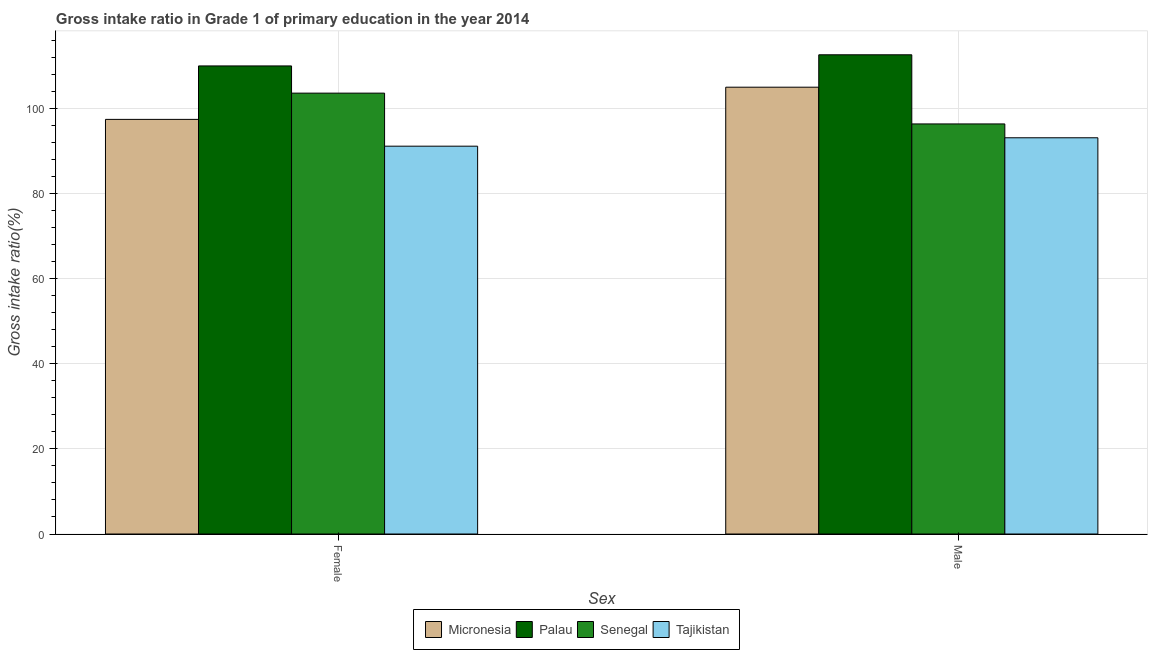How many different coloured bars are there?
Make the answer very short. 4. How many groups of bars are there?
Ensure brevity in your answer.  2. Are the number of bars per tick equal to the number of legend labels?
Make the answer very short. Yes. How many bars are there on the 1st tick from the left?
Make the answer very short. 4. What is the label of the 1st group of bars from the left?
Your answer should be compact. Female. What is the gross intake ratio(male) in Senegal?
Offer a terse response. 96.45. Across all countries, what is the maximum gross intake ratio(female)?
Offer a very short reply. 110.09. Across all countries, what is the minimum gross intake ratio(male)?
Your answer should be very brief. 93.19. In which country was the gross intake ratio(female) maximum?
Offer a terse response. Palau. In which country was the gross intake ratio(male) minimum?
Give a very brief answer. Tajikistan. What is the total gross intake ratio(female) in the graph?
Offer a very short reply. 402.52. What is the difference between the gross intake ratio(male) in Palau and that in Tajikistan?
Provide a succinct answer. 19.52. What is the difference between the gross intake ratio(female) in Tajikistan and the gross intake ratio(male) in Palau?
Make the answer very short. -21.5. What is the average gross intake ratio(female) per country?
Give a very brief answer. 100.63. What is the difference between the gross intake ratio(female) and gross intake ratio(male) in Micronesia?
Offer a very short reply. -7.57. What is the ratio of the gross intake ratio(female) in Palau to that in Senegal?
Give a very brief answer. 1.06. Is the gross intake ratio(male) in Palau less than that in Micronesia?
Keep it short and to the point. No. What does the 2nd bar from the left in Female represents?
Provide a succinct answer. Palau. What does the 3rd bar from the right in Female represents?
Keep it short and to the point. Palau. Are all the bars in the graph horizontal?
Provide a succinct answer. No. How many countries are there in the graph?
Make the answer very short. 4. What is the difference between two consecutive major ticks on the Y-axis?
Your response must be concise. 20. Does the graph contain grids?
Make the answer very short. Yes. How many legend labels are there?
Ensure brevity in your answer.  4. How are the legend labels stacked?
Your answer should be compact. Horizontal. What is the title of the graph?
Offer a very short reply. Gross intake ratio in Grade 1 of primary education in the year 2014. What is the label or title of the X-axis?
Your response must be concise. Sex. What is the label or title of the Y-axis?
Make the answer very short. Gross intake ratio(%). What is the Gross intake ratio(%) of Micronesia in Female?
Provide a short and direct response. 97.52. What is the Gross intake ratio(%) in Palau in Female?
Keep it short and to the point. 110.09. What is the Gross intake ratio(%) of Senegal in Female?
Offer a very short reply. 103.69. What is the Gross intake ratio(%) of Tajikistan in Female?
Your answer should be compact. 91.22. What is the Gross intake ratio(%) in Micronesia in Male?
Ensure brevity in your answer.  105.09. What is the Gross intake ratio(%) of Palau in Male?
Give a very brief answer. 112.71. What is the Gross intake ratio(%) in Senegal in Male?
Make the answer very short. 96.45. What is the Gross intake ratio(%) of Tajikistan in Male?
Provide a succinct answer. 93.19. Across all Sex, what is the maximum Gross intake ratio(%) of Micronesia?
Give a very brief answer. 105.09. Across all Sex, what is the maximum Gross intake ratio(%) in Palau?
Make the answer very short. 112.71. Across all Sex, what is the maximum Gross intake ratio(%) of Senegal?
Your response must be concise. 103.69. Across all Sex, what is the maximum Gross intake ratio(%) in Tajikistan?
Provide a short and direct response. 93.19. Across all Sex, what is the minimum Gross intake ratio(%) of Micronesia?
Offer a terse response. 97.52. Across all Sex, what is the minimum Gross intake ratio(%) in Palau?
Your answer should be very brief. 110.09. Across all Sex, what is the minimum Gross intake ratio(%) of Senegal?
Give a very brief answer. 96.45. Across all Sex, what is the minimum Gross intake ratio(%) of Tajikistan?
Provide a short and direct response. 91.22. What is the total Gross intake ratio(%) of Micronesia in the graph?
Give a very brief answer. 202.61. What is the total Gross intake ratio(%) in Palau in the graph?
Give a very brief answer. 222.8. What is the total Gross intake ratio(%) in Senegal in the graph?
Your answer should be very brief. 200.14. What is the total Gross intake ratio(%) of Tajikistan in the graph?
Ensure brevity in your answer.  184.41. What is the difference between the Gross intake ratio(%) of Micronesia in Female and that in Male?
Provide a succinct answer. -7.57. What is the difference between the Gross intake ratio(%) in Palau in Female and that in Male?
Make the answer very short. -2.62. What is the difference between the Gross intake ratio(%) in Senegal in Female and that in Male?
Offer a terse response. 7.24. What is the difference between the Gross intake ratio(%) of Tajikistan in Female and that in Male?
Make the answer very short. -1.98. What is the difference between the Gross intake ratio(%) in Micronesia in Female and the Gross intake ratio(%) in Palau in Male?
Provide a succinct answer. -15.19. What is the difference between the Gross intake ratio(%) of Micronesia in Female and the Gross intake ratio(%) of Senegal in Male?
Ensure brevity in your answer.  1.07. What is the difference between the Gross intake ratio(%) of Micronesia in Female and the Gross intake ratio(%) of Tajikistan in Male?
Provide a short and direct response. 4.33. What is the difference between the Gross intake ratio(%) in Palau in Female and the Gross intake ratio(%) in Senegal in Male?
Keep it short and to the point. 13.64. What is the difference between the Gross intake ratio(%) of Palau in Female and the Gross intake ratio(%) of Tajikistan in Male?
Offer a terse response. 16.9. What is the difference between the Gross intake ratio(%) of Senegal in Female and the Gross intake ratio(%) of Tajikistan in Male?
Provide a succinct answer. 10.5. What is the average Gross intake ratio(%) of Micronesia per Sex?
Your response must be concise. 101.31. What is the average Gross intake ratio(%) in Palau per Sex?
Your answer should be very brief. 111.4. What is the average Gross intake ratio(%) in Senegal per Sex?
Your response must be concise. 100.07. What is the average Gross intake ratio(%) in Tajikistan per Sex?
Ensure brevity in your answer.  92.21. What is the difference between the Gross intake ratio(%) in Micronesia and Gross intake ratio(%) in Palau in Female?
Offer a very short reply. -12.57. What is the difference between the Gross intake ratio(%) of Micronesia and Gross intake ratio(%) of Senegal in Female?
Provide a short and direct response. -6.17. What is the difference between the Gross intake ratio(%) in Micronesia and Gross intake ratio(%) in Tajikistan in Female?
Your answer should be compact. 6.3. What is the difference between the Gross intake ratio(%) of Palau and Gross intake ratio(%) of Senegal in Female?
Ensure brevity in your answer.  6.4. What is the difference between the Gross intake ratio(%) in Palau and Gross intake ratio(%) in Tajikistan in Female?
Keep it short and to the point. 18.88. What is the difference between the Gross intake ratio(%) of Senegal and Gross intake ratio(%) of Tajikistan in Female?
Offer a very short reply. 12.48. What is the difference between the Gross intake ratio(%) in Micronesia and Gross intake ratio(%) in Palau in Male?
Give a very brief answer. -7.62. What is the difference between the Gross intake ratio(%) in Micronesia and Gross intake ratio(%) in Senegal in Male?
Offer a terse response. 8.64. What is the difference between the Gross intake ratio(%) in Micronesia and Gross intake ratio(%) in Tajikistan in Male?
Make the answer very short. 11.9. What is the difference between the Gross intake ratio(%) in Palau and Gross intake ratio(%) in Senegal in Male?
Your response must be concise. 16.26. What is the difference between the Gross intake ratio(%) of Palau and Gross intake ratio(%) of Tajikistan in Male?
Ensure brevity in your answer.  19.52. What is the difference between the Gross intake ratio(%) in Senegal and Gross intake ratio(%) in Tajikistan in Male?
Ensure brevity in your answer.  3.25. What is the ratio of the Gross intake ratio(%) in Micronesia in Female to that in Male?
Provide a succinct answer. 0.93. What is the ratio of the Gross intake ratio(%) of Palau in Female to that in Male?
Keep it short and to the point. 0.98. What is the ratio of the Gross intake ratio(%) in Senegal in Female to that in Male?
Provide a succinct answer. 1.08. What is the ratio of the Gross intake ratio(%) of Tajikistan in Female to that in Male?
Offer a terse response. 0.98. What is the difference between the highest and the second highest Gross intake ratio(%) of Micronesia?
Ensure brevity in your answer.  7.57. What is the difference between the highest and the second highest Gross intake ratio(%) of Palau?
Offer a terse response. 2.62. What is the difference between the highest and the second highest Gross intake ratio(%) of Senegal?
Keep it short and to the point. 7.24. What is the difference between the highest and the second highest Gross intake ratio(%) of Tajikistan?
Keep it short and to the point. 1.98. What is the difference between the highest and the lowest Gross intake ratio(%) of Micronesia?
Provide a short and direct response. 7.57. What is the difference between the highest and the lowest Gross intake ratio(%) in Palau?
Your response must be concise. 2.62. What is the difference between the highest and the lowest Gross intake ratio(%) in Senegal?
Your response must be concise. 7.24. What is the difference between the highest and the lowest Gross intake ratio(%) of Tajikistan?
Provide a succinct answer. 1.98. 